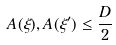Convert formula to latex. <formula><loc_0><loc_0><loc_500><loc_500>A ( \xi ) , A ( \xi ^ { \prime } ) \leq \frac { D } { 2 }</formula> 